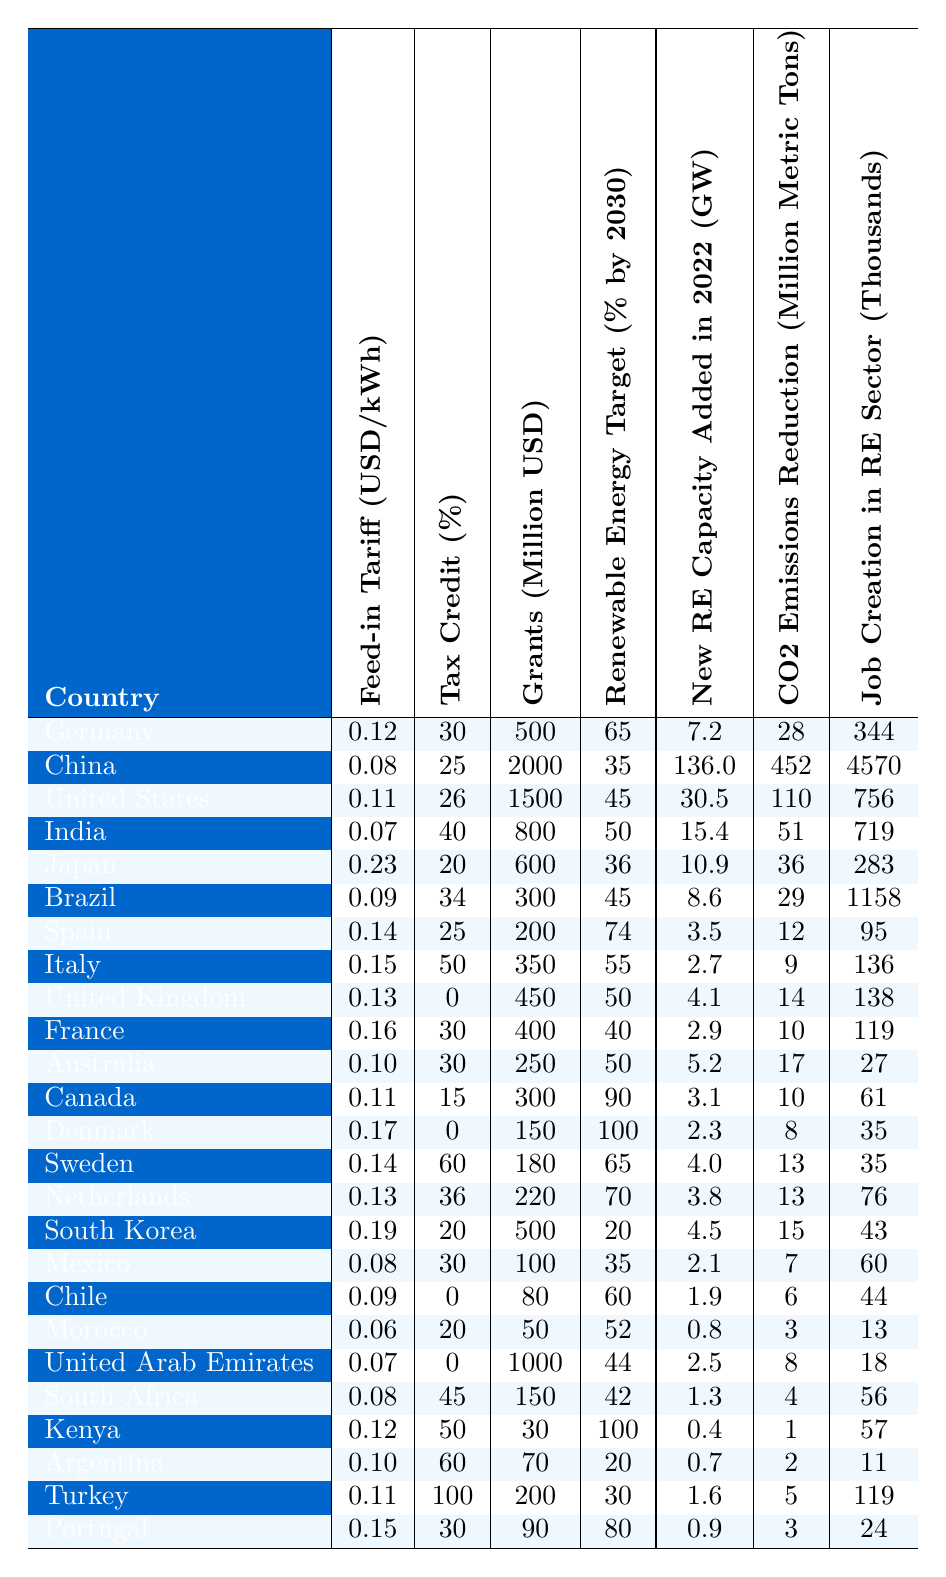What's the highest feed-in tariff among the countries listed? By analyzing the "Feed-in Tariff" column, we can see that Japan has the highest value at 0.23 USD/kWh.
Answer: 0.23 USD/kWh Which country has the lowest tax credit percentage? Looking at the "Tax Credit (%)" column, the country with the lowest tax credit percentage is the United Kingdom with 0%.
Answer: 0% What country provided the most grants for renewable energy projects? From the "Grants (Million USD)" column, we see that China provided the most grants at 2000 million USD.
Answer: 2000 million USD How many countries have a renewable energy target of 100% by 2030? By checking the "Renewable Energy Target (% by 2030)" column, we find that Denmark and Portugal are the only two countries with 100% targets.
Answer: 2 What is the average amount of new renewable energy capacity added in 2022 across all listed countries? To find this, we must add all the "New Renewable Energy Capacity Added in 2022 (GW)" values and divide by the number of countries (25). The total is 218.5 GW, so the average is 218.5/25 = 8.74 GW.
Answer: 8.74 GW Is there a correlation between grants and job creation in the renewable energy sector? To analyze this, we would compare the "Grants (Million USD)" and "Job Creation in Renewable Sector (Thousands)" columns for trends. There does seem to be a positive correlation in several cases, but thorough statistical analysis would be needed for confirmation.
Answer: Yes, but requires analysis Which country produced the highest CO2 emissions reduction in million metric tons in 2022? Referring to the "CO2 Emissions Reduction (Million Metric Tons)" column, China is the country with the highest reduction at 452 million metric tons.
Answer: 452 million metric tons How many more jobs were created in the renewable sector in China compared to the United States? By subtracting job creation figures, China created 4570 - 756 = 3814 more jobs than the United States in the renewable energy sector.
Answer: 3814 What is the total feed-in tariff for the countries that have a tax credit above 50%? Based on the "Feed-in Tariff (USD/kWh)" column for countries with a tax credit greater than 50%, we calculate the total: (0.19 + 0.17 + 0.15 + 0.15 + 0.11) = 0.77 USD/kWh.
Answer: 0.77 USD/kWh Is the job creation in Kenya higher than that in Morocco? Kenya has 57 thousand jobs while Morocco has 13 thousand jobs, thus job creation in Kenya is indeed higher than in Morocco.
Answer: Yes What country has the highest renewable energy target percentage and what is the value? In the "Renewable Energy Target (% by 2030)" column, Denmark and Portugal both have a renewable energy target of 100%.
Answer: Denmark and Portugal, 100% 